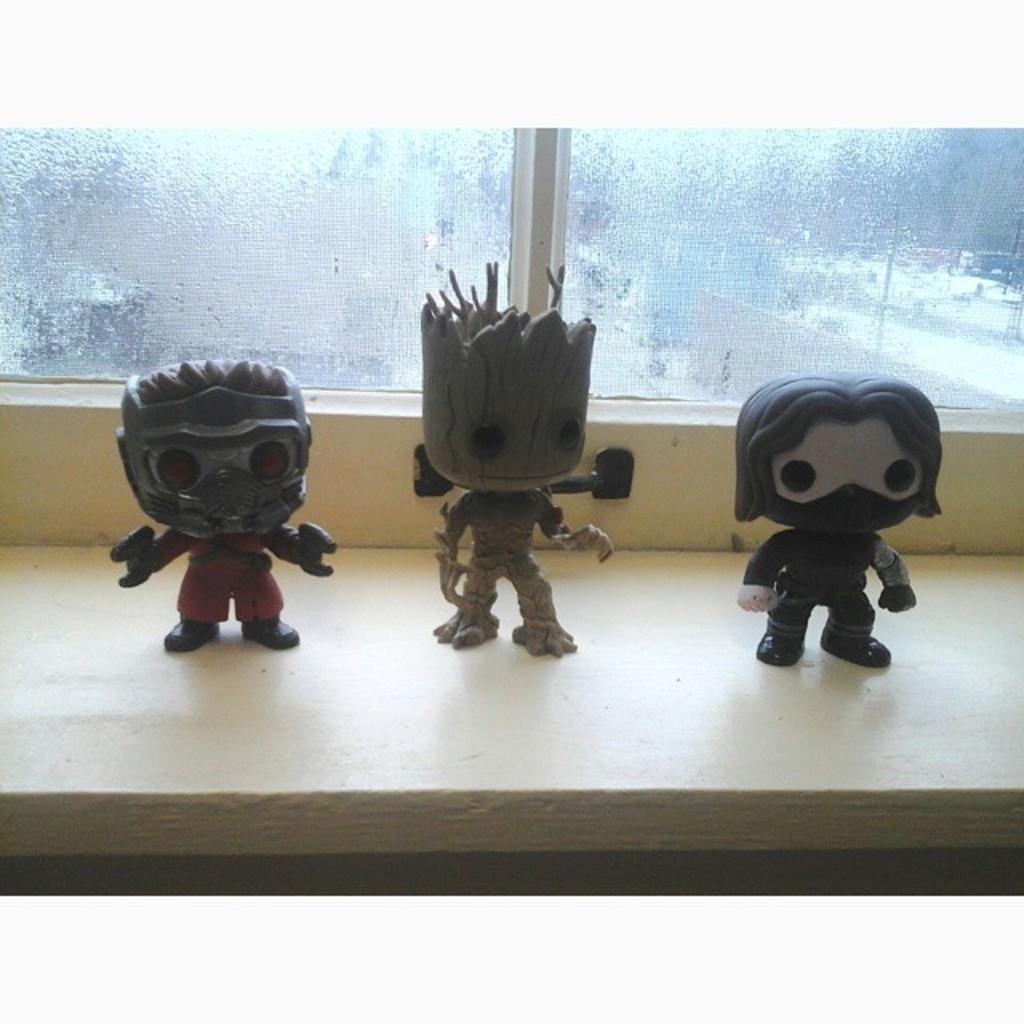Please provide a concise description of this image. In this image there are three toys near to the windows. In the center there is a groot toy. Behind them there are glass windows. 